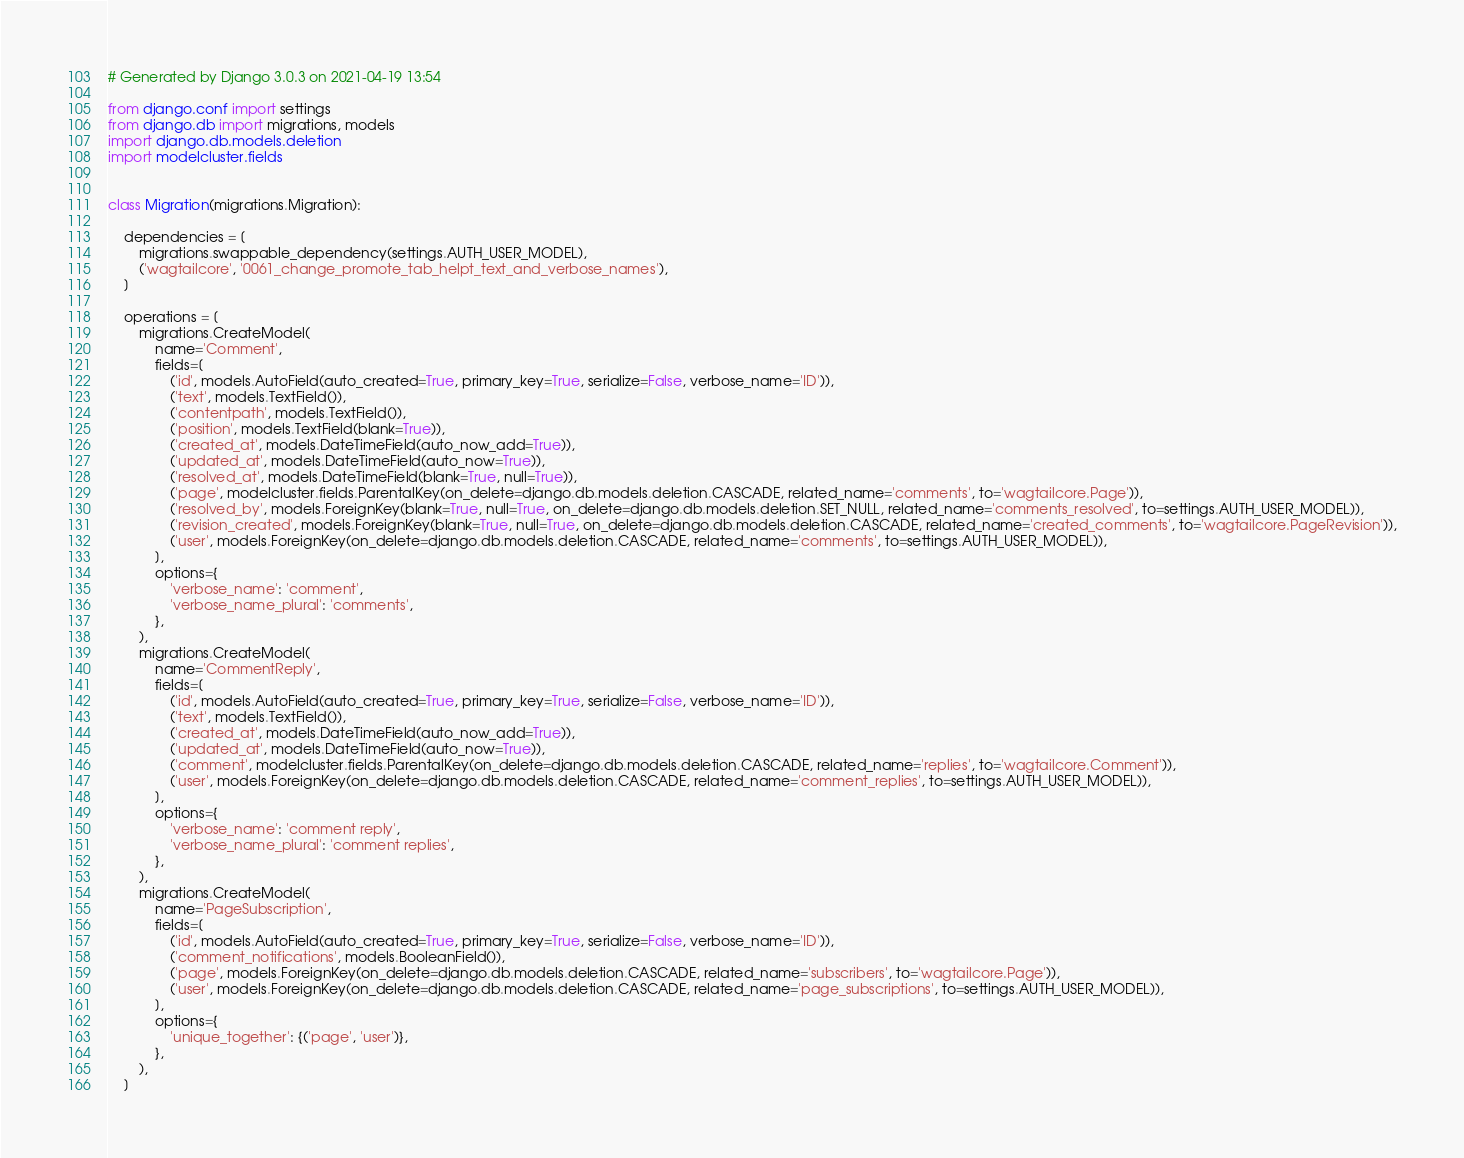Convert code to text. <code><loc_0><loc_0><loc_500><loc_500><_Python_># Generated by Django 3.0.3 on 2021-04-19 13:54

from django.conf import settings
from django.db import migrations, models
import django.db.models.deletion
import modelcluster.fields


class Migration(migrations.Migration):

    dependencies = [
        migrations.swappable_dependency(settings.AUTH_USER_MODEL),
        ('wagtailcore', '0061_change_promote_tab_helpt_text_and_verbose_names'),
    ]

    operations = [
        migrations.CreateModel(
            name='Comment',
            fields=[
                ('id', models.AutoField(auto_created=True, primary_key=True, serialize=False, verbose_name='ID')),
                ('text', models.TextField()),
                ('contentpath', models.TextField()),
                ('position', models.TextField(blank=True)),
                ('created_at', models.DateTimeField(auto_now_add=True)),
                ('updated_at', models.DateTimeField(auto_now=True)),
                ('resolved_at', models.DateTimeField(blank=True, null=True)),
                ('page', modelcluster.fields.ParentalKey(on_delete=django.db.models.deletion.CASCADE, related_name='comments', to='wagtailcore.Page')),
                ('resolved_by', models.ForeignKey(blank=True, null=True, on_delete=django.db.models.deletion.SET_NULL, related_name='comments_resolved', to=settings.AUTH_USER_MODEL)),
                ('revision_created', models.ForeignKey(blank=True, null=True, on_delete=django.db.models.deletion.CASCADE, related_name='created_comments', to='wagtailcore.PageRevision')),
                ('user', models.ForeignKey(on_delete=django.db.models.deletion.CASCADE, related_name='comments', to=settings.AUTH_USER_MODEL)),
            ],
            options={
                'verbose_name': 'comment',
                'verbose_name_plural': 'comments',
            },
        ),
        migrations.CreateModel(
            name='CommentReply',
            fields=[
                ('id', models.AutoField(auto_created=True, primary_key=True, serialize=False, verbose_name='ID')),
                ('text', models.TextField()),
                ('created_at', models.DateTimeField(auto_now_add=True)),
                ('updated_at', models.DateTimeField(auto_now=True)),
                ('comment', modelcluster.fields.ParentalKey(on_delete=django.db.models.deletion.CASCADE, related_name='replies', to='wagtailcore.Comment')),
                ('user', models.ForeignKey(on_delete=django.db.models.deletion.CASCADE, related_name='comment_replies', to=settings.AUTH_USER_MODEL)),
            ],
            options={
                'verbose_name': 'comment reply',
                'verbose_name_plural': 'comment replies',
            },
        ),
        migrations.CreateModel(
            name='PageSubscription',
            fields=[
                ('id', models.AutoField(auto_created=True, primary_key=True, serialize=False, verbose_name='ID')),
                ('comment_notifications', models.BooleanField()),
                ('page', models.ForeignKey(on_delete=django.db.models.deletion.CASCADE, related_name='subscribers', to='wagtailcore.Page')),
                ('user', models.ForeignKey(on_delete=django.db.models.deletion.CASCADE, related_name='page_subscriptions', to=settings.AUTH_USER_MODEL)),
            ],
            options={
                'unique_together': {('page', 'user')},
            },
        ),
    ]
</code> 